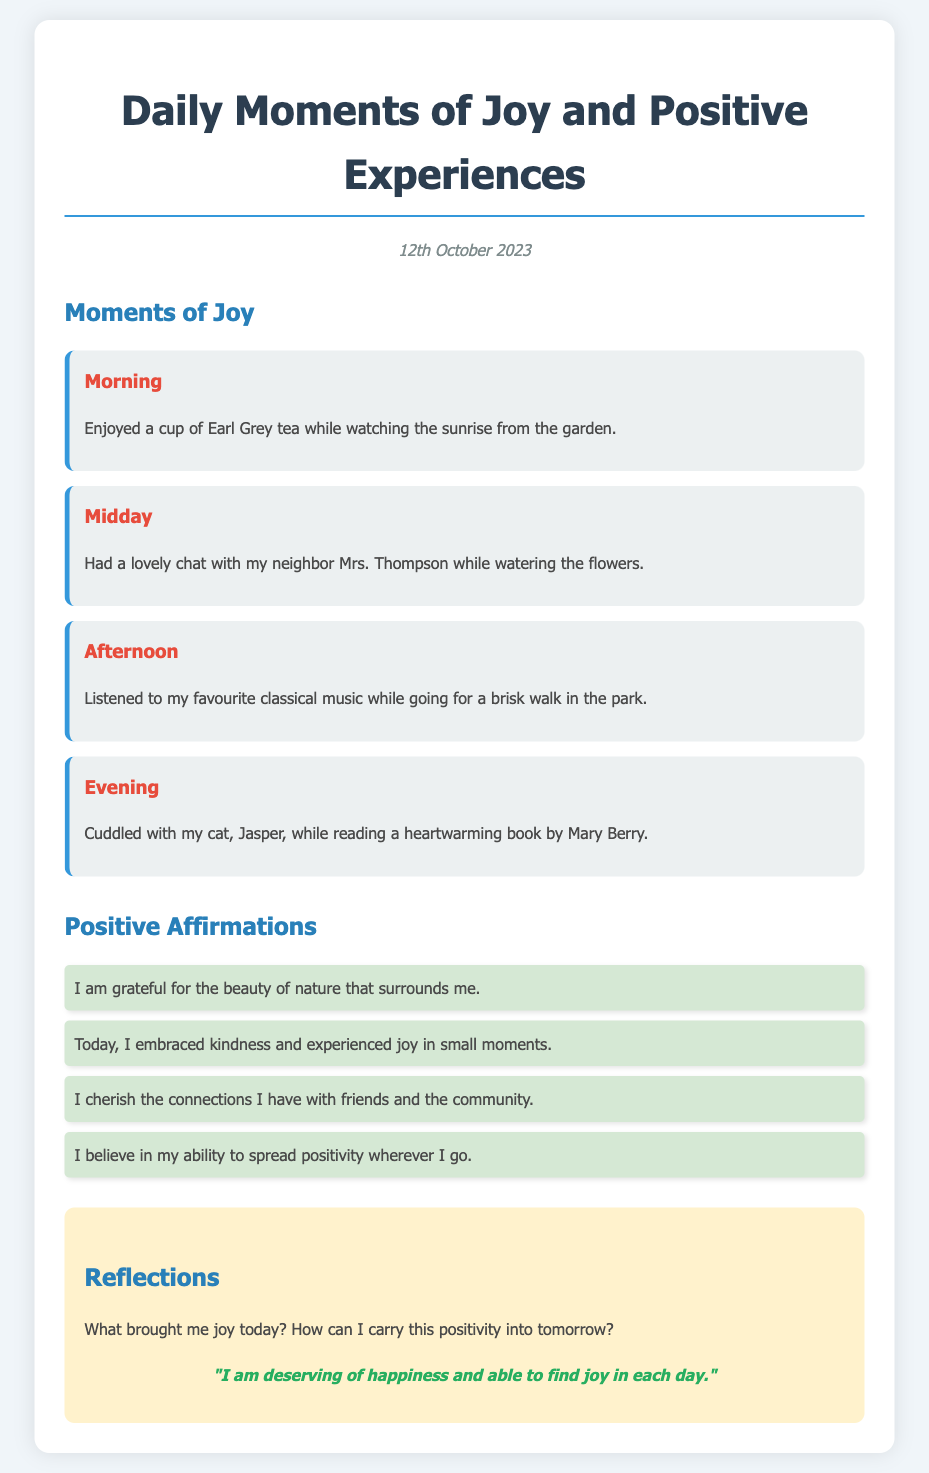What is the title of the document? The title of the document is indicated at the top of the page in a prominent font.
Answer: Daily Moments of Joy and Positive Experiences What date is mentioned in the document? The date is presented in the "date" section near the title.
Answer: 12th October 2023 How many moments of joy are listed in the document? The document provides a section specifically for moments of joy, where each moment is detailed.
Answer: Four What activity did the author do in the morning? The morning section describes a joyful activity experienced by the author.
Answer: Enjoyed a cup of Earl Grey tea What positive affirmation relates to nature? One of the affirmations includes gratitude towards nature, highlighting its beauty.
Answer: I am grateful for the beauty of nature that surrounds me What question do the reflections section pose? The reflections section includes two questions aimed at contemplating the day's joy.
Answer: What brought me joy today? What book did the author read in the evening? The evening moment describes a specific book the author was reading at that time.
Answer: A heartwarming book by Mary Berry What sentiment is expressed in the personal affirmation? The personal affirmation conveys a specific belief the author holds about happiness.
Answer: I am deserving of happiness and able to find joy in each day 